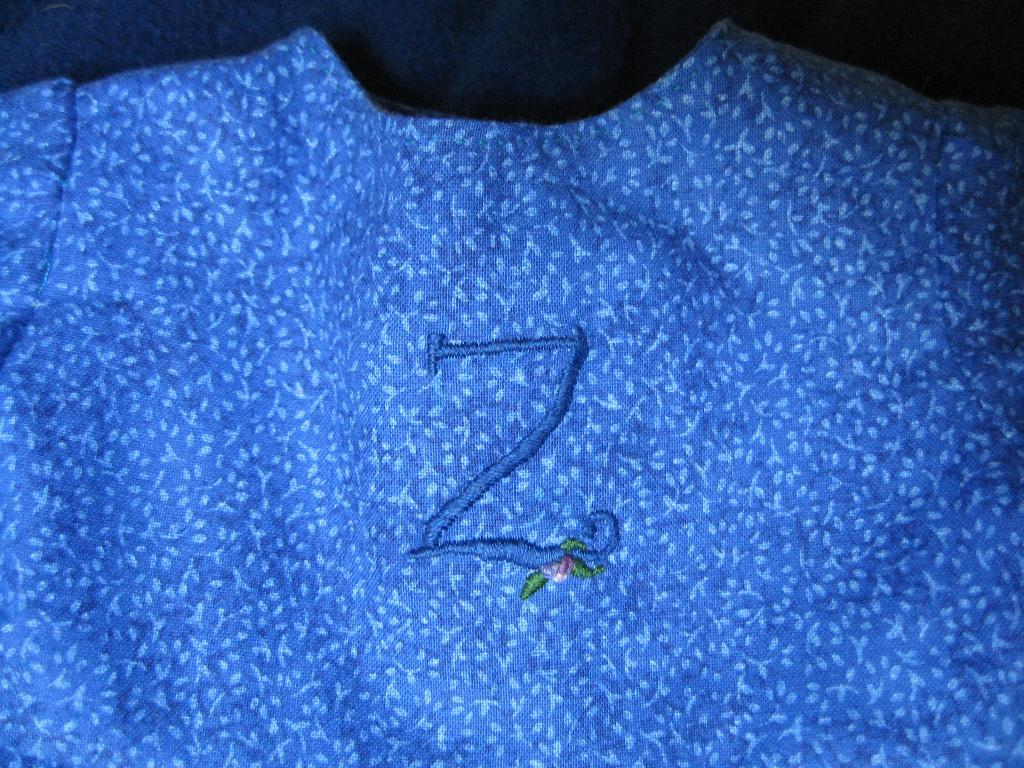What is the main subject in the center of the image? There is a clot present in the center of the image. What type of lip can be seen on the duck in the image? There is no duck or lip present in the image; it only features a clot. 